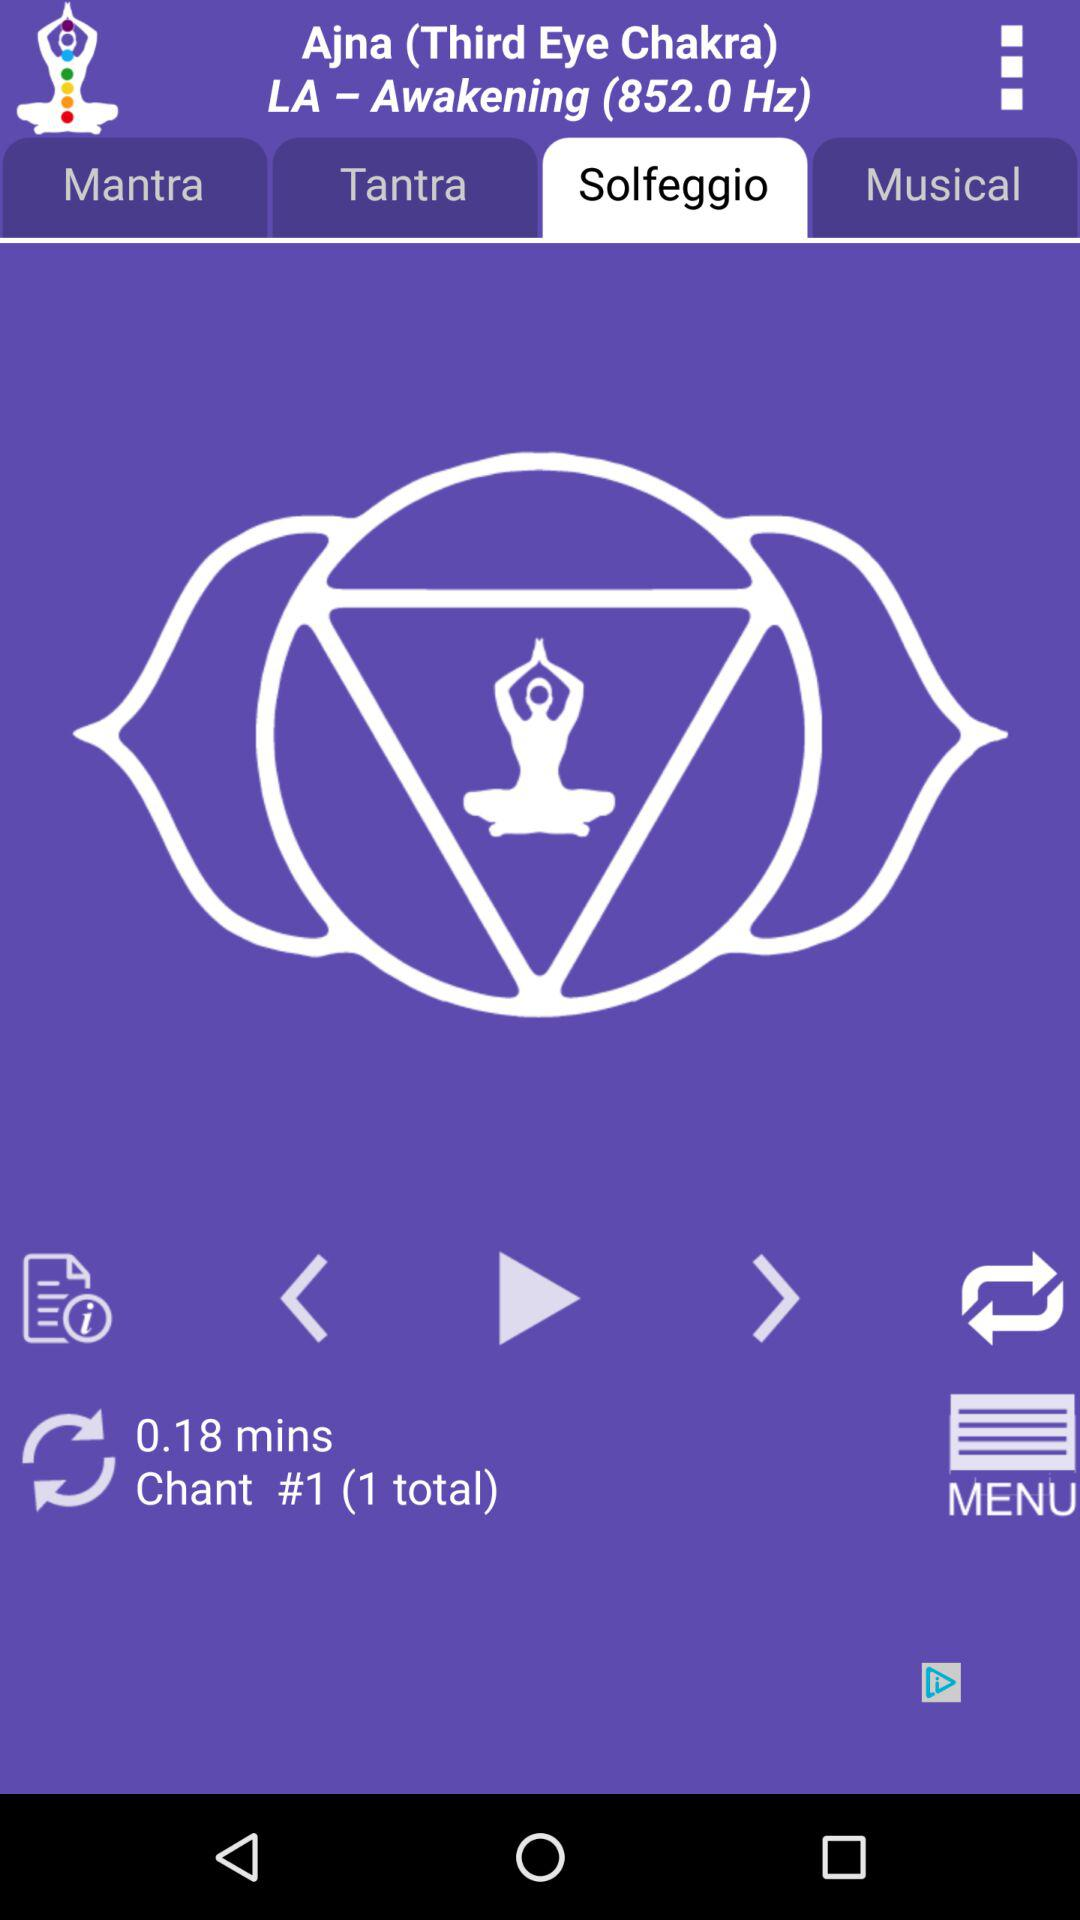What is the count of "Chant"? The count of "Chant" is 1. 